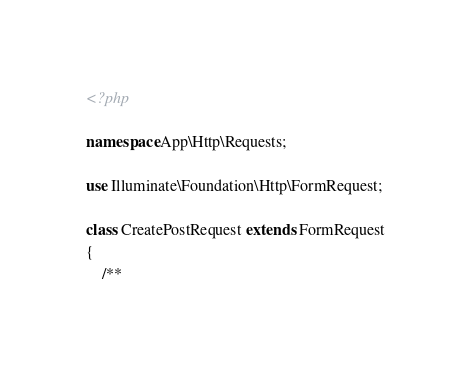Convert code to text. <code><loc_0><loc_0><loc_500><loc_500><_PHP_><?php

namespace App\Http\Requests;

use Illuminate\Foundation\Http\FormRequest;

class CreatePostRequest extends FormRequest
{
    /**</code> 